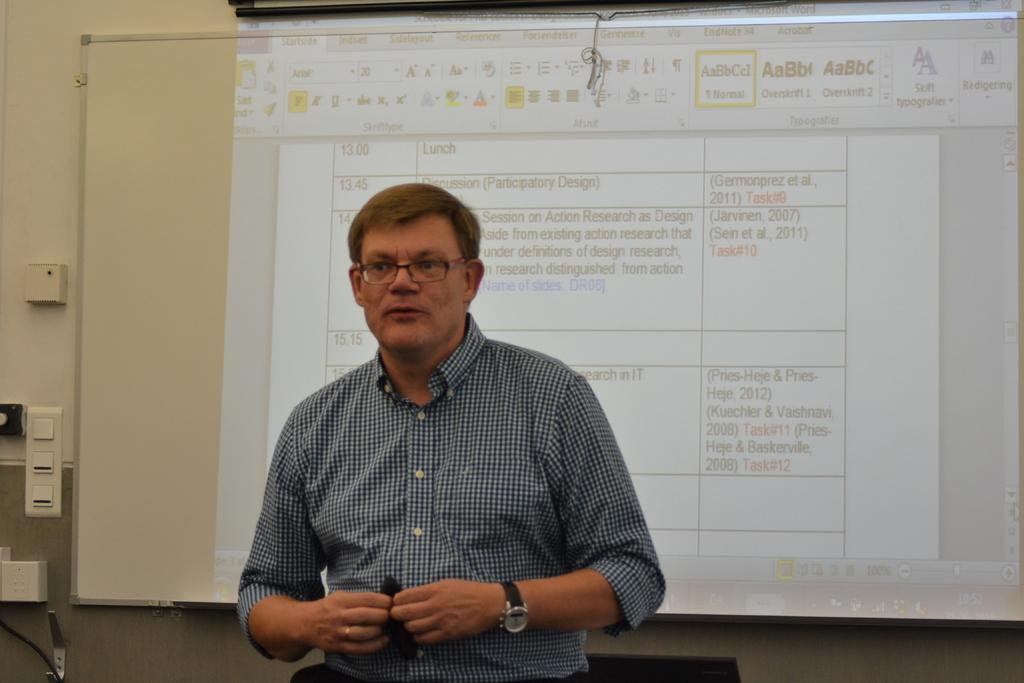What is the main subject in the image? There is a person standing in the image. What is located behind the person? There is a screen behind the person. What type of equipment can be seen in the image? There is a switch board in the image. What else is visible in the image? There are cables visible in the image. What can be seen in the background of the image? There is a wall in the background of the image. What type of writing can be seen on the wall in the image? There is no writing visible on the wall in the image. Is there a door present in the image? There is no door visible in the image. 